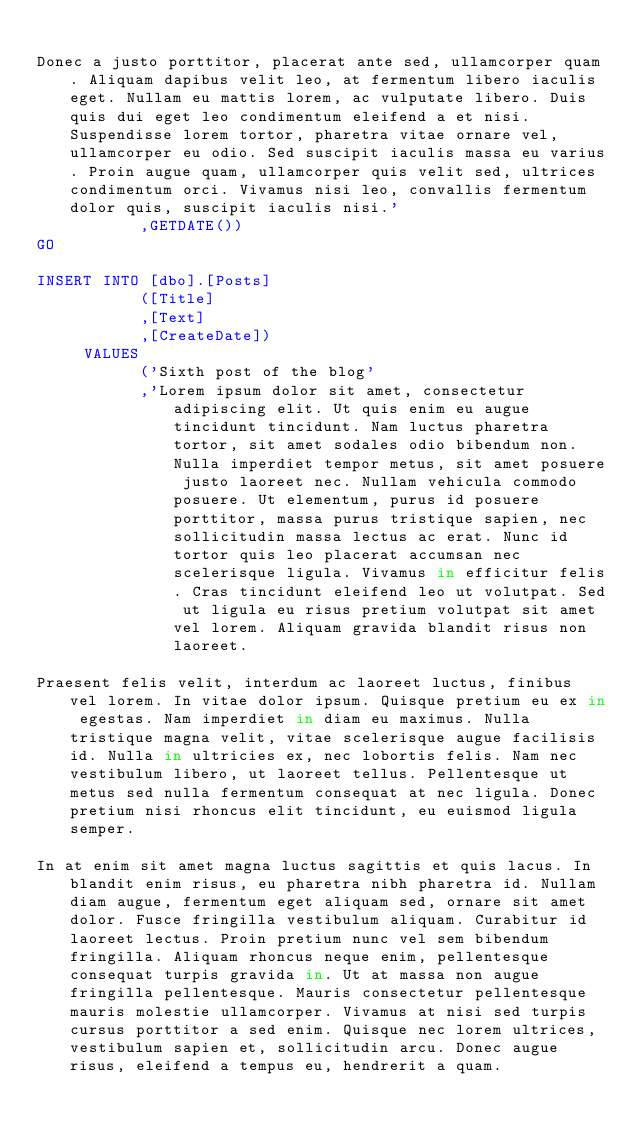Convert code to text. <code><loc_0><loc_0><loc_500><loc_500><_SQL_>
Donec a justo porttitor, placerat ante sed, ullamcorper quam. Aliquam dapibus velit leo, at fermentum libero iaculis eget. Nullam eu mattis lorem, ac vulputate libero. Duis quis dui eget leo condimentum eleifend a et nisi. Suspendisse lorem tortor, pharetra vitae ornare vel, ullamcorper eu odio. Sed suscipit iaculis massa eu varius. Proin augue quam, ullamcorper quis velit sed, ultrices condimentum orci. Vivamus nisi leo, convallis fermentum dolor quis, suscipit iaculis nisi.'
           ,GETDATE())
GO

INSERT INTO [dbo].[Posts]
           ([Title]
           ,[Text]
           ,[CreateDate])
     VALUES
           ('Sixth post of the blog'
           ,'Lorem ipsum dolor sit amet, consectetur adipiscing elit. Ut quis enim eu augue tincidunt tincidunt. Nam luctus pharetra tortor, sit amet sodales odio bibendum non. Nulla imperdiet tempor metus, sit amet posuere justo laoreet nec. Nullam vehicula commodo posuere. Ut elementum, purus id posuere porttitor, massa purus tristique sapien, nec sollicitudin massa lectus ac erat. Nunc id tortor quis leo placerat accumsan nec scelerisque ligula. Vivamus in efficitur felis. Cras tincidunt eleifend leo ut volutpat. Sed ut ligula eu risus pretium volutpat sit amet vel lorem. Aliquam gravida blandit risus non laoreet.

Praesent felis velit, interdum ac laoreet luctus, finibus vel lorem. In vitae dolor ipsum. Quisque pretium eu ex in egestas. Nam imperdiet in diam eu maximus. Nulla tristique magna velit, vitae scelerisque augue facilisis id. Nulla in ultricies ex, nec lobortis felis. Nam nec vestibulum libero, ut laoreet tellus. Pellentesque ut metus sed nulla fermentum consequat at nec ligula. Donec pretium nisi rhoncus elit tincidunt, eu euismod ligula semper.

In at enim sit amet magna luctus sagittis et quis lacus. In blandit enim risus, eu pharetra nibh pharetra id. Nullam diam augue, fermentum eget aliquam sed, ornare sit amet dolor. Fusce fringilla vestibulum aliquam. Curabitur id laoreet lectus. Proin pretium nunc vel sem bibendum fringilla. Aliquam rhoncus neque enim, pellentesque consequat turpis gravida in. Ut at massa non augue fringilla pellentesque. Mauris consectetur pellentesque mauris molestie ullamcorper. Vivamus at nisi sed turpis cursus porttitor a sed enim. Quisque nec lorem ultrices, vestibulum sapien et, sollicitudin arcu. Donec augue risus, eleifend a tempus eu, hendrerit a quam.
</code> 